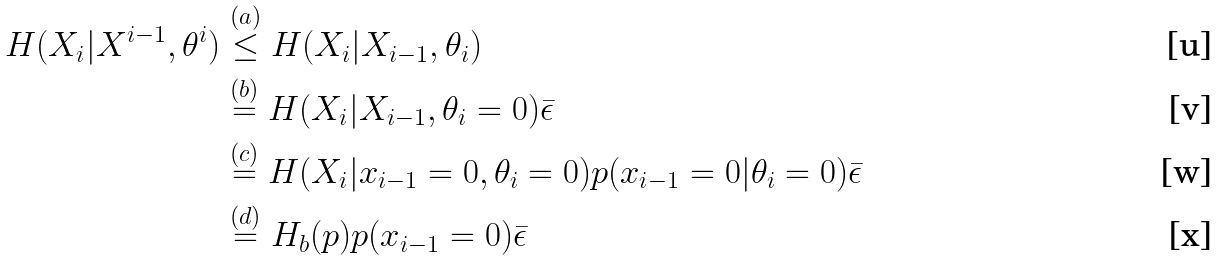<formula> <loc_0><loc_0><loc_500><loc_500>H ( X _ { i } | X ^ { i - 1 } , \theta ^ { i } ) & \stackrel { ( a ) } \leq H ( X _ { i } | X _ { i - 1 } , \theta _ { i } ) \\ & \stackrel { ( b ) } = H ( X _ { i } | X _ { i - 1 } , \theta _ { i } = 0 ) \bar { \epsilon } \\ & \stackrel { ( c ) } = H ( X _ { i } | x _ { i - 1 } = 0 , \theta _ { i } = 0 ) p ( x _ { i - 1 } = 0 | \theta _ { i } = 0 ) \bar { \epsilon } \\ & \stackrel { ( d ) } = H _ { b } ( p ) p ( x _ { i - 1 } = 0 ) \bar { \epsilon }</formula> 